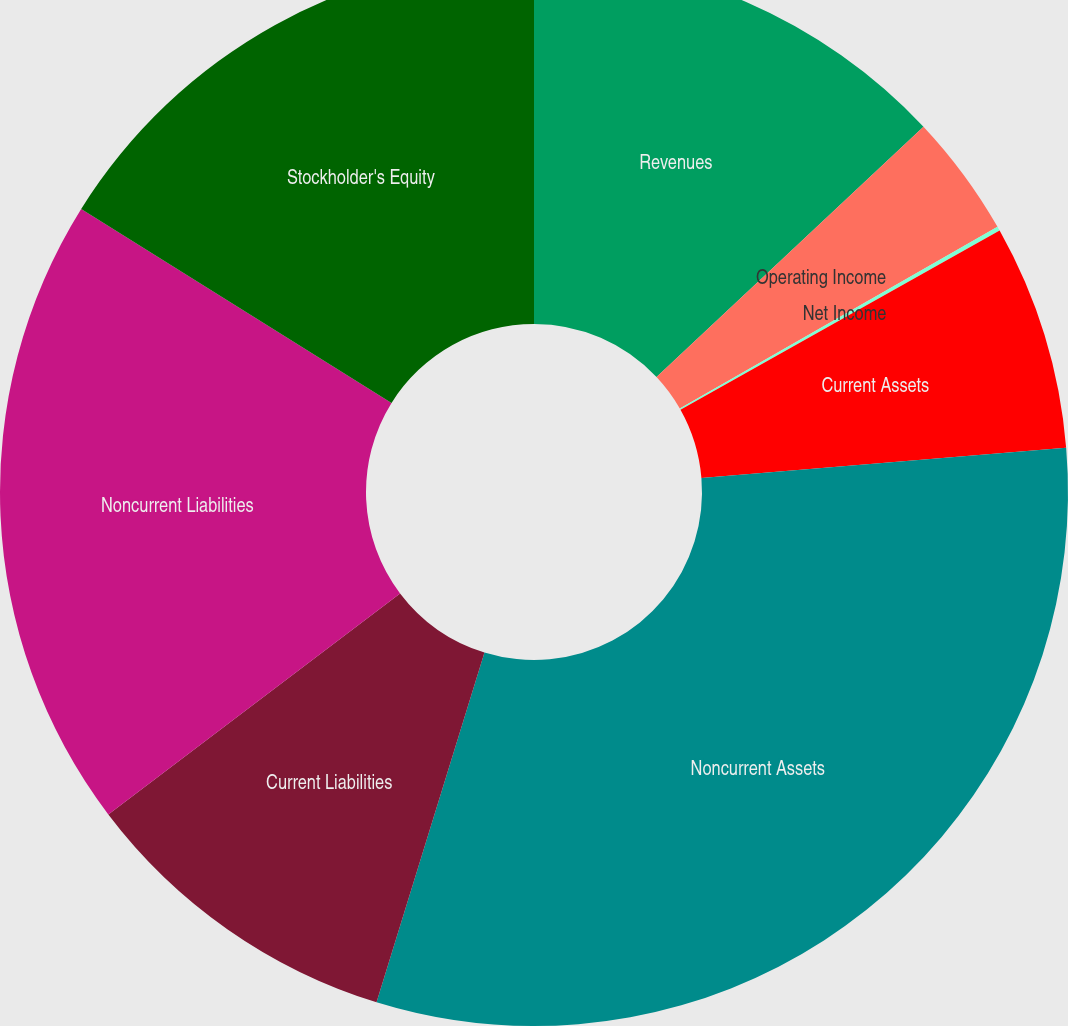Convert chart to OTSL. <chart><loc_0><loc_0><loc_500><loc_500><pie_chart><fcel>Revenues<fcel>Operating Income<fcel>Net Income<fcel>Current Assets<fcel>Noncurrent Assets<fcel>Current Liabilities<fcel>Noncurrent Liabilities<fcel>Stockholder's Equity<nl><fcel>13.01%<fcel>3.72%<fcel>0.13%<fcel>6.82%<fcel>31.09%<fcel>9.92%<fcel>19.21%<fcel>16.11%<nl></chart> 